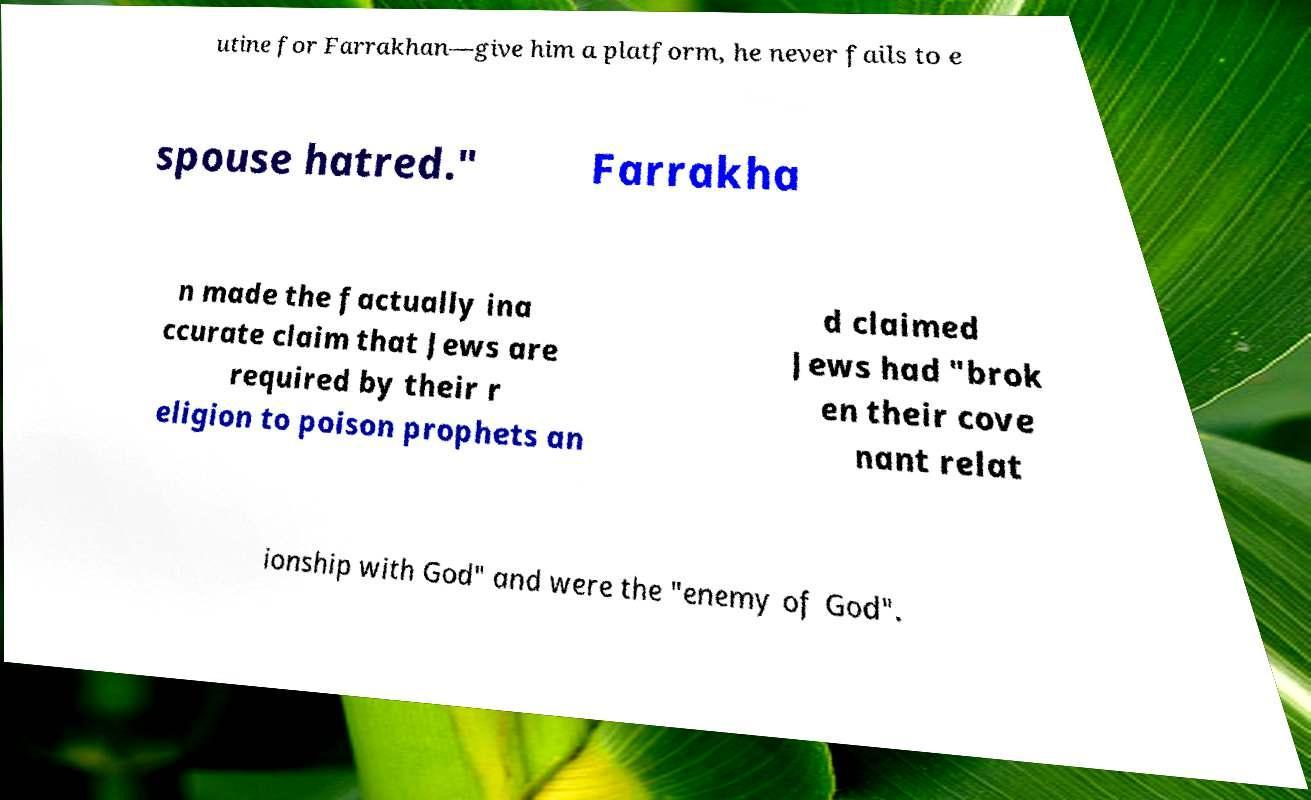What messages or text are displayed in this image? I need them in a readable, typed format. utine for Farrakhan—give him a platform, he never fails to e spouse hatred." Farrakha n made the factually ina ccurate claim that Jews are required by their r eligion to poison prophets an d claimed Jews had "brok en their cove nant relat ionship with God" and were the "enemy of God". 